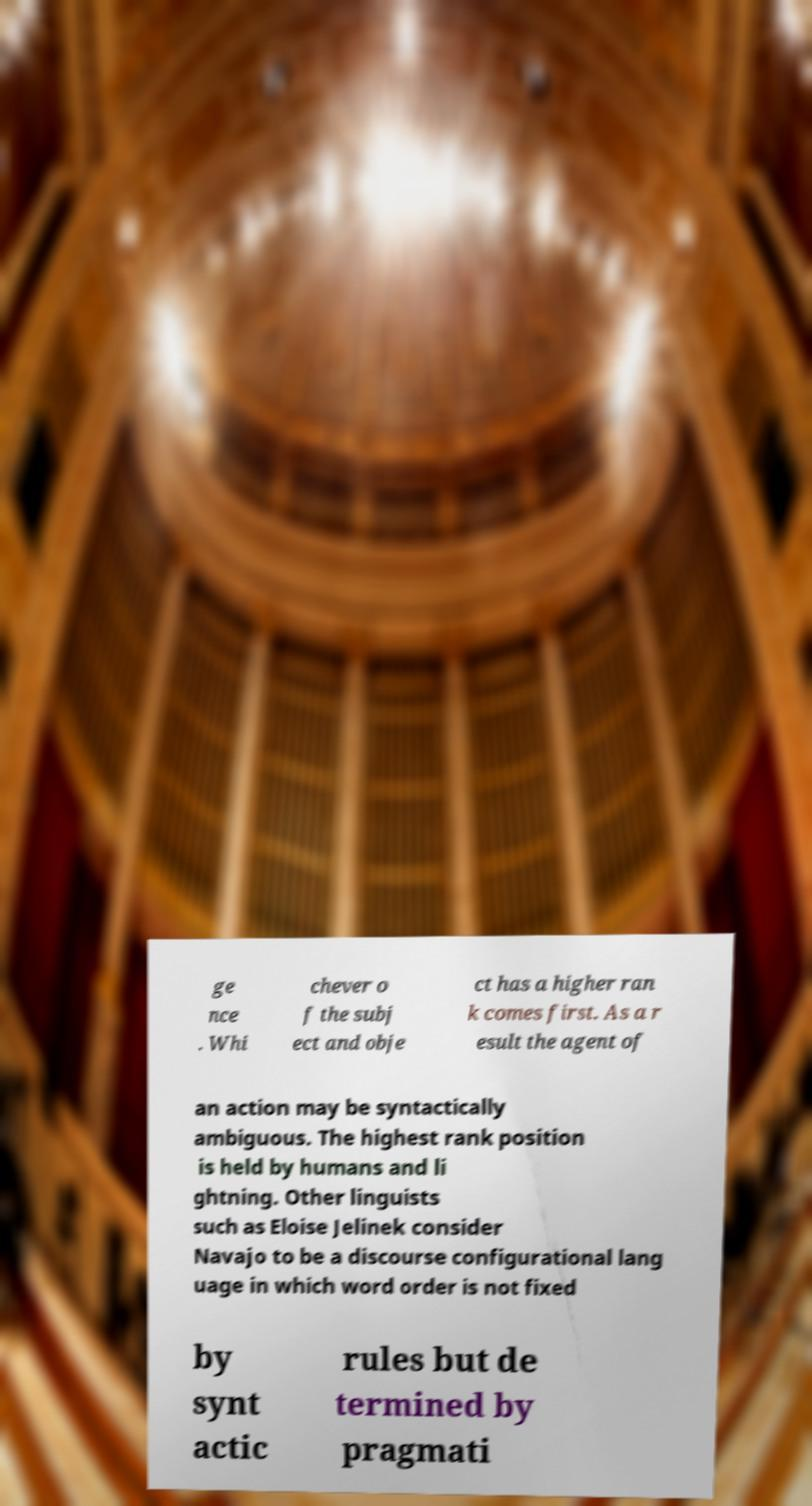For documentation purposes, I need the text within this image transcribed. Could you provide that? ge nce . Whi chever o f the subj ect and obje ct has a higher ran k comes first. As a r esult the agent of an action may be syntactically ambiguous. The highest rank position is held by humans and li ghtning. Other linguists such as Eloise Jelinek consider Navajo to be a discourse configurational lang uage in which word order is not fixed by synt actic rules but de termined by pragmati 